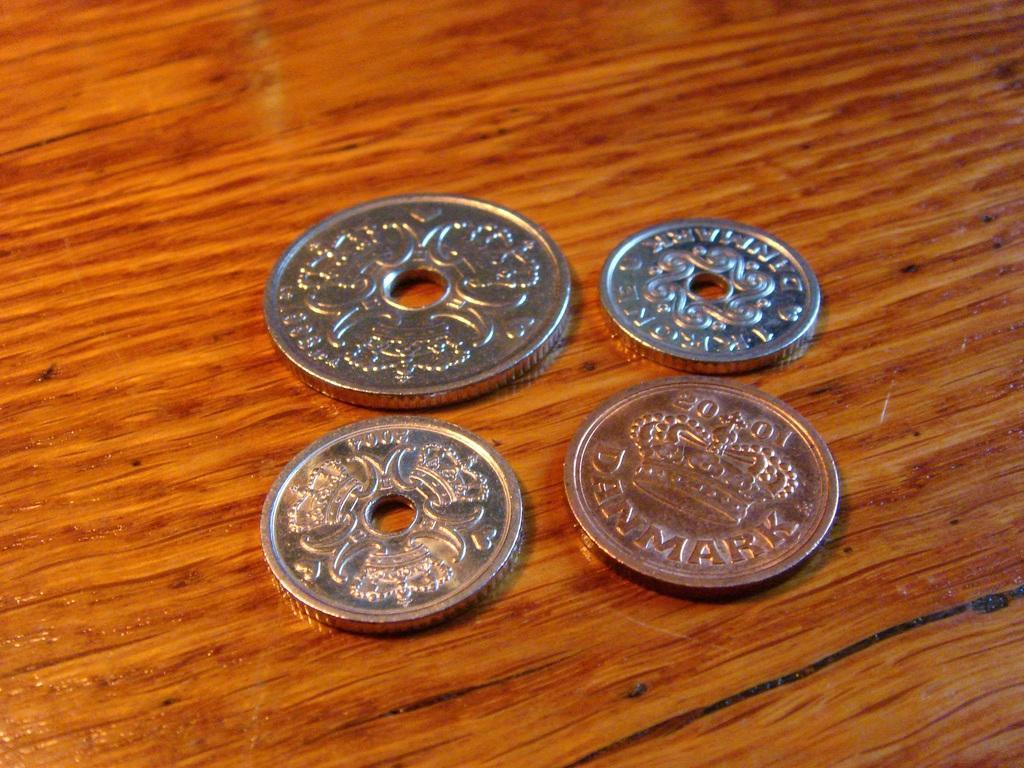Could you give a brief overview of what you see in this image? In this image I can see 4 coins on a wooden surface. There are holes in the center of 3 coins. 